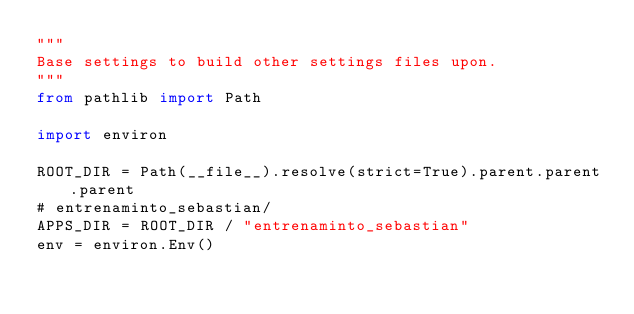<code> <loc_0><loc_0><loc_500><loc_500><_Python_>"""
Base settings to build other settings files upon.
"""
from pathlib import Path

import environ

ROOT_DIR = Path(__file__).resolve(strict=True).parent.parent.parent
# entrenaminto_sebastian/
APPS_DIR = ROOT_DIR / "entrenaminto_sebastian"
env = environ.Env()
</code> 